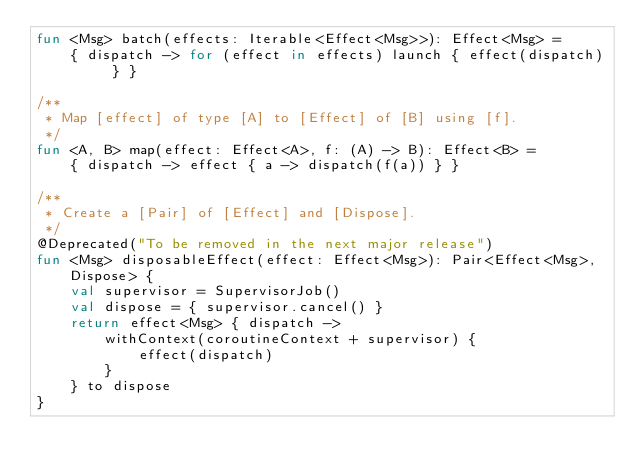Convert code to text. <code><loc_0><loc_0><loc_500><loc_500><_Kotlin_>fun <Msg> batch(effects: Iterable<Effect<Msg>>): Effect<Msg> =
    { dispatch -> for (effect in effects) launch { effect(dispatch) } }

/**
 * Map [effect] of type [A] to [Effect] of [B] using [f].
 */
fun <A, B> map(effect: Effect<A>, f: (A) -> B): Effect<B> =
    { dispatch -> effect { a -> dispatch(f(a)) } }

/**
 * Create a [Pair] of [Effect] and [Dispose].
 */
@Deprecated("To be removed in the next major release")
fun <Msg> disposableEffect(effect: Effect<Msg>): Pair<Effect<Msg>, Dispose> {
    val supervisor = SupervisorJob()
    val dispose = { supervisor.cancel() }
    return effect<Msg> { dispatch ->
        withContext(coroutineContext + supervisor) {
            effect(dispatch)
        }
    } to dispose
}
</code> 